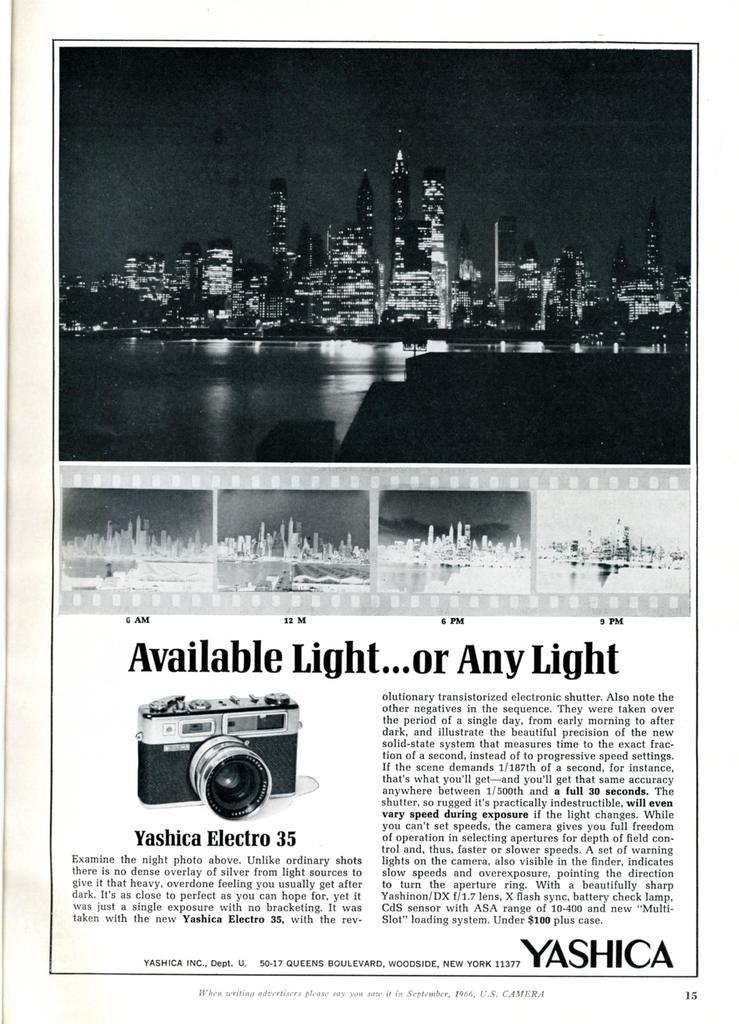<image>
Create a compact narrative representing the image presented. A Yashica Electro 35 is showcased in a newspaper ad. 